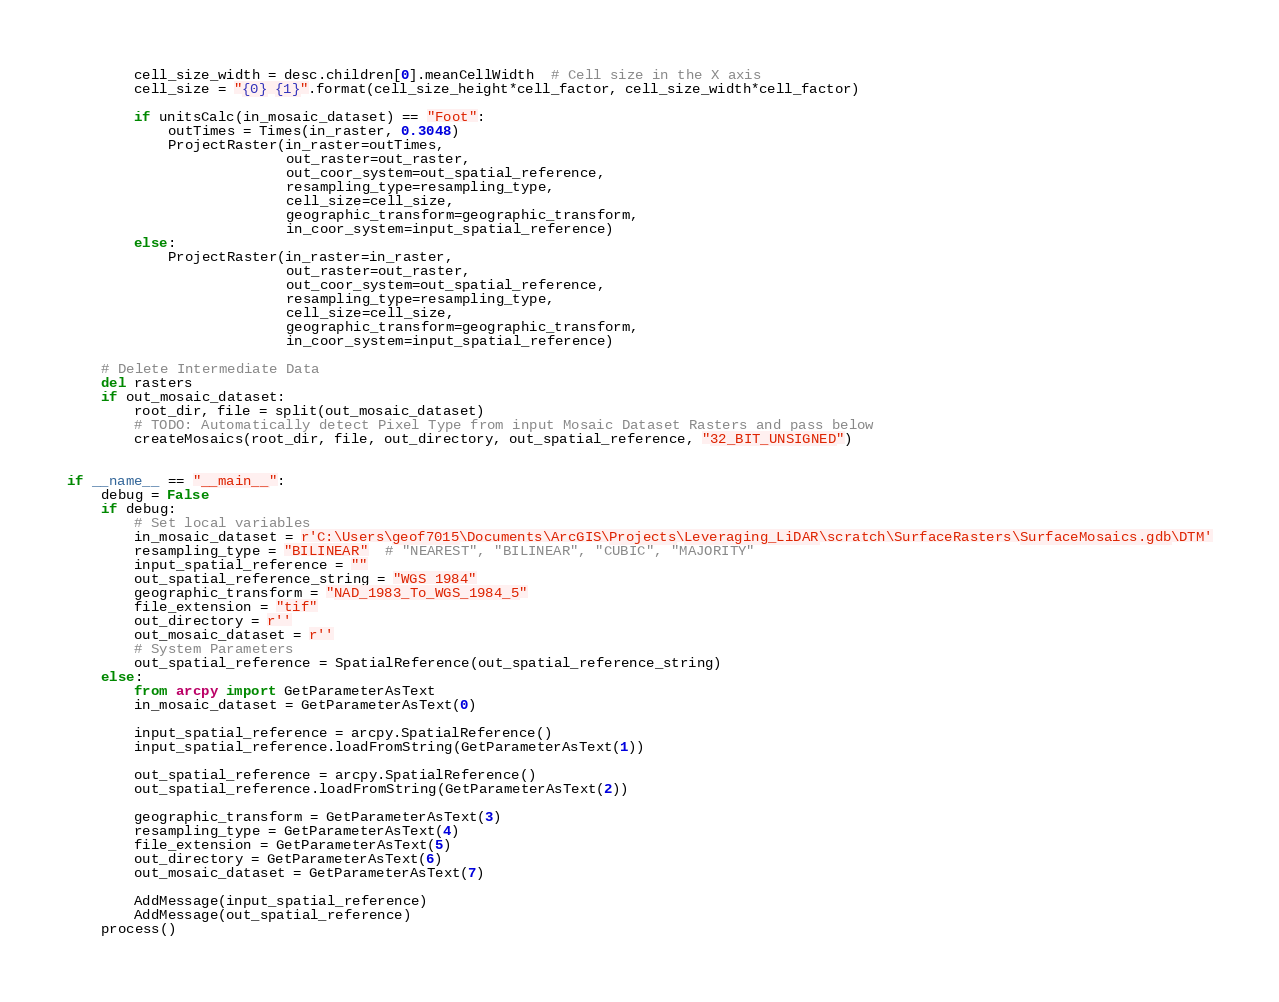Convert code to text. <code><loc_0><loc_0><loc_500><loc_500><_Python_>        cell_size_width = desc.children[0].meanCellWidth  # Cell size in the X axis
        cell_size = "{0} {1}".format(cell_size_height*cell_factor, cell_size_width*cell_factor)

        if unitsCalc(in_mosaic_dataset) == "Foot":
            outTimes = Times(in_raster, 0.3048)
            ProjectRaster(in_raster=outTimes,
                          out_raster=out_raster,
                          out_coor_system=out_spatial_reference,
                          resampling_type=resampling_type,
                          cell_size=cell_size,
                          geographic_transform=geographic_transform,
                          in_coor_system=input_spatial_reference)
        else:
            ProjectRaster(in_raster=in_raster,
                          out_raster=out_raster,
                          out_coor_system=out_spatial_reference,
                          resampling_type=resampling_type,
                          cell_size=cell_size,
                          geographic_transform=geographic_transform,
                          in_coor_system=input_spatial_reference)

    # Delete Intermediate Data
    del rasters
    if out_mosaic_dataset:
        root_dir, file = split(out_mosaic_dataset)
        # TODO: Automatically detect Pixel Type from input Mosaic Dataset Rasters and pass below
        createMosaics(root_dir, file, out_directory, out_spatial_reference, "32_BIT_UNSIGNED")


if __name__ == "__main__":
    debug = False
    if debug:
        # Set local variables
        in_mosaic_dataset = r'C:\Users\geof7015\Documents\ArcGIS\Projects\Leveraging_LiDAR\scratch\SurfaceRasters\SurfaceMosaics.gdb\DTM'
        resampling_type = "BILINEAR"  # "NEAREST", "BILINEAR", "CUBIC", "MAJORITY"
        input_spatial_reference = ""
        out_spatial_reference_string = "WGS 1984"
        geographic_transform = "NAD_1983_To_WGS_1984_5"
        file_extension = "tif"
        out_directory = r''
        out_mosaic_dataset = r''
        # System Parameters
        out_spatial_reference = SpatialReference(out_spatial_reference_string)
    else:
        from arcpy import GetParameterAsText
        in_mosaic_dataset = GetParameterAsText(0)

        input_spatial_reference = arcpy.SpatialReference()
        input_spatial_reference.loadFromString(GetParameterAsText(1))

        out_spatial_reference = arcpy.SpatialReference()
        out_spatial_reference.loadFromString(GetParameterAsText(2))

        geographic_transform = GetParameterAsText(3)
        resampling_type = GetParameterAsText(4)
        file_extension = GetParameterAsText(5)
        out_directory = GetParameterAsText(6)
        out_mosaic_dataset = GetParameterAsText(7)

        AddMessage(input_spatial_reference)
        AddMessage(out_spatial_reference)
    process()
</code> 